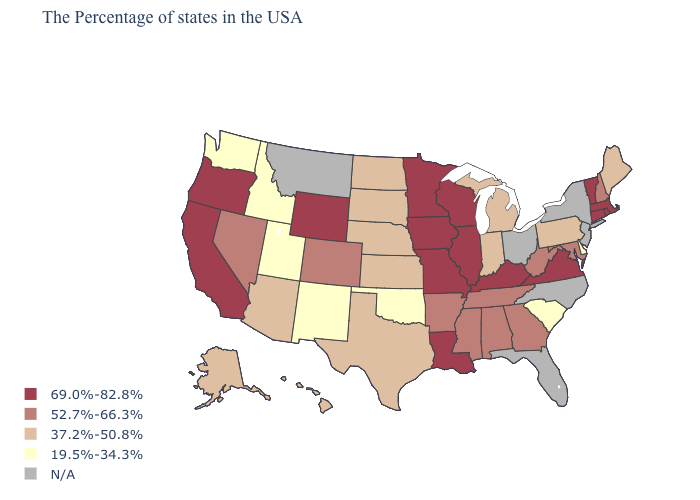Does the map have missing data?
Short answer required. Yes. Among the states that border Michigan , does Wisconsin have the highest value?
Short answer required. Yes. Name the states that have a value in the range 19.5%-34.3%?
Give a very brief answer. Delaware, South Carolina, Oklahoma, New Mexico, Utah, Idaho, Washington. Which states hav the highest value in the MidWest?
Keep it brief. Wisconsin, Illinois, Missouri, Minnesota, Iowa. Which states have the highest value in the USA?
Give a very brief answer. Massachusetts, Rhode Island, Vermont, Connecticut, Virginia, Kentucky, Wisconsin, Illinois, Louisiana, Missouri, Minnesota, Iowa, Wyoming, California, Oregon. What is the lowest value in the USA?
Keep it brief. 19.5%-34.3%. Name the states that have a value in the range 37.2%-50.8%?
Write a very short answer. Maine, Pennsylvania, Michigan, Indiana, Kansas, Nebraska, Texas, South Dakota, North Dakota, Arizona, Alaska, Hawaii. Name the states that have a value in the range N/A?
Write a very short answer. New York, New Jersey, North Carolina, Ohio, Florida, Montana. What is the value of Wyoming?
Give a very brief answer. 69.0%-82.8%. What is the lowest value in states that border Wyoming?
Give a very brief answer. 19.5%-34.3%. What is the lowest value in the USA?
Keep it brief. 19.5%-34.3%. What is the value of Indiana?
Concise answer only. 37.2%-50.8%. Name the states that have a value in the range N/A?
Short answer required. New York, New Jersey, North Carolina, Ohio, Florida, Montana. Among the states that border Vermont , does Massachusetts have the highest value?
Be succinct. Yes. Does the first symbol in the legend represent the smallest category?
Short answer required. No. 